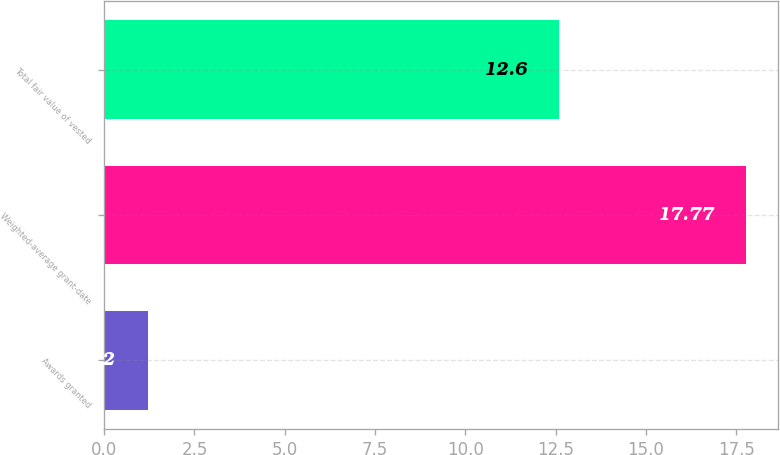Convert chart. <chart><loc_0><loc_0><loc_500><loc_500><bar_chart><fcel>Awards granted<fcel>Weighted-average grant-date<fcel>Total fair value of vested<nl><fcel>1.2<fcel>17.77<fcel>12.6<nl></chart> 